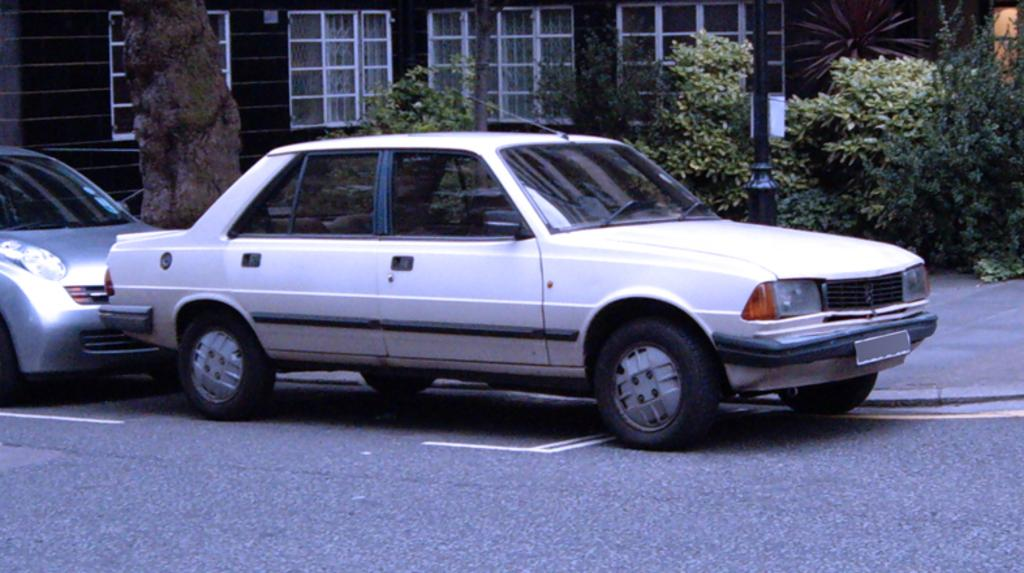What type of vehicles can be seen on the road in the image? There are cars on the road in the image. What structure is visible in the background of the image? There is a house with windows in the background of the image. What type of natural element is present in the image? There is a tree in the image. What type of vegetation is present in the image? There are plants in the image. Reasoning: Let' Let's think step by step in order to produce the conversation. We start by identifying the main subjects and objects in the image based on the provided facts. We then formulate questions that focus on the location and characteristics of these subjects and objects, ensuring that each question can be answered definitively with the information given. We avoid yes/no questions and ensure that the language is simple and clear. Absurd Question/Answer: What type of mountain can be seen in the image? There is no mountain present in the image. What songs are being sung by the plants in the image? There are no songs being sung by the plants in the image, as plants do not have the ability to sing. 